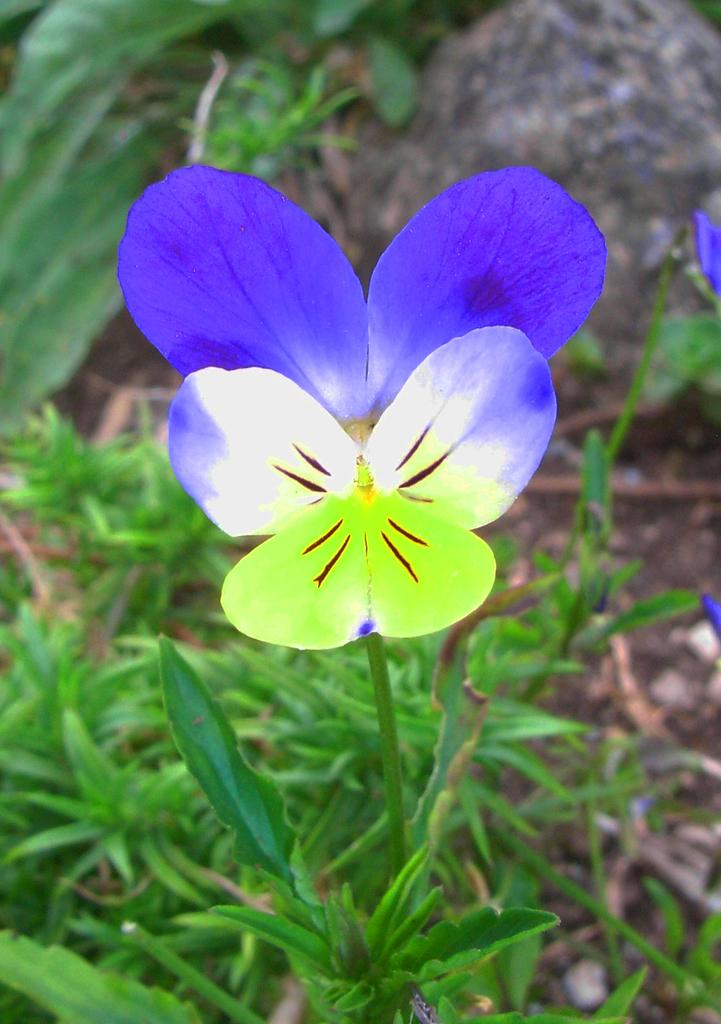What type of vegetation can be seen in the image? There are flowers, plants, and grass in the image. Can you describe the different types of vegetation present? The image contains flowers, plants, and grass. What is the primary color of the grass in the image? The grass in the image is green. What type of silver beam can be seen supporting the curtain in the image? There is no silver beam or curtain present in the image; it features flowers, plants, and grass. 